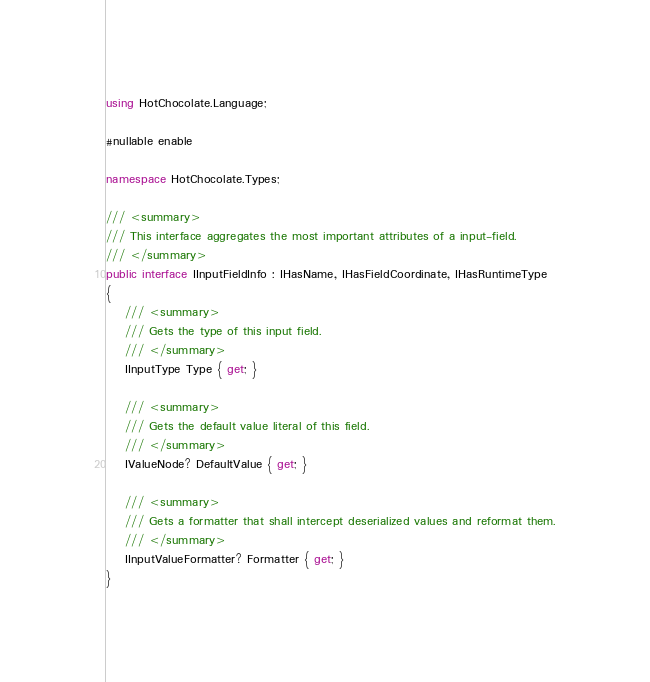<code> <loc_0><loc_0><loc_500><loc_500><_C#_>using HotChocolate.Language;

#nullable enable

namespace HotChocolate.Types;

/// <summary>
/// This interface aggregates the most important attributes of a input-field.
/// </summary>
public interface IInputFieldInfo : IHasName, IHasFieldCoordinate, IHasRuntimeType
{
    /// <summary>
    /// Gets the type of this input field.
    /// </summary>
    IInputType Type { get; }

    /// <summary>
    /// Gets the default value literal of this field.
    /// </summary>
    IValueNode? DefaultValue { get; }

    /// <summary>
    /// Gets a formatter that shall intercept deserialized values and reformat them.
    /// </summary>
    IInputValueFormatter? Formatter { get; }
}
</code> 